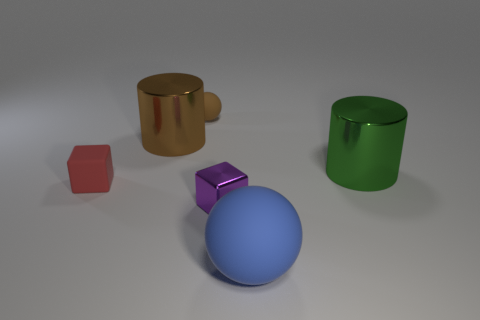Do the big metallic object on the left side of the green cylinder and the tiny thing that is behind the brown metallic thing have the same shape?
Your answer should be very brief. No. There is a brown object that is the same size as the green metal cylinder; what is it made of?
Your answer should be compact. Metal. There is a large thing that is left of the rubber sphere that is behind the tiny purple object; what is its shape?
Your answer should be compact. Cylinder. How many objects are large balls or things to the left of the big green cylinder?
Offer a very short reply. 5. What number of other things are there of the same color as the tiny rubber sphere?
Provide a succinct answer. 1. How many blue objects are big matte things or small metallic things?
Your answer should be very brief. 1. Are there any small things that are on the left side of the shiny thing behind the big thing that is on the right side of the large blue ball?
Offer a terse response. Yes. There is a small block to the right of the small red matte block that is to the left of the big brown cylinder; what color is it?
Your answer should be compact. Purple. How many tiny objects are rubber things or brown things?
Keep it short and to the point. 2. The rubber object that is both behind the large rubber object and to the right of the red rubber cube is what color?
Ensure brevity in your answer.  Brown. 